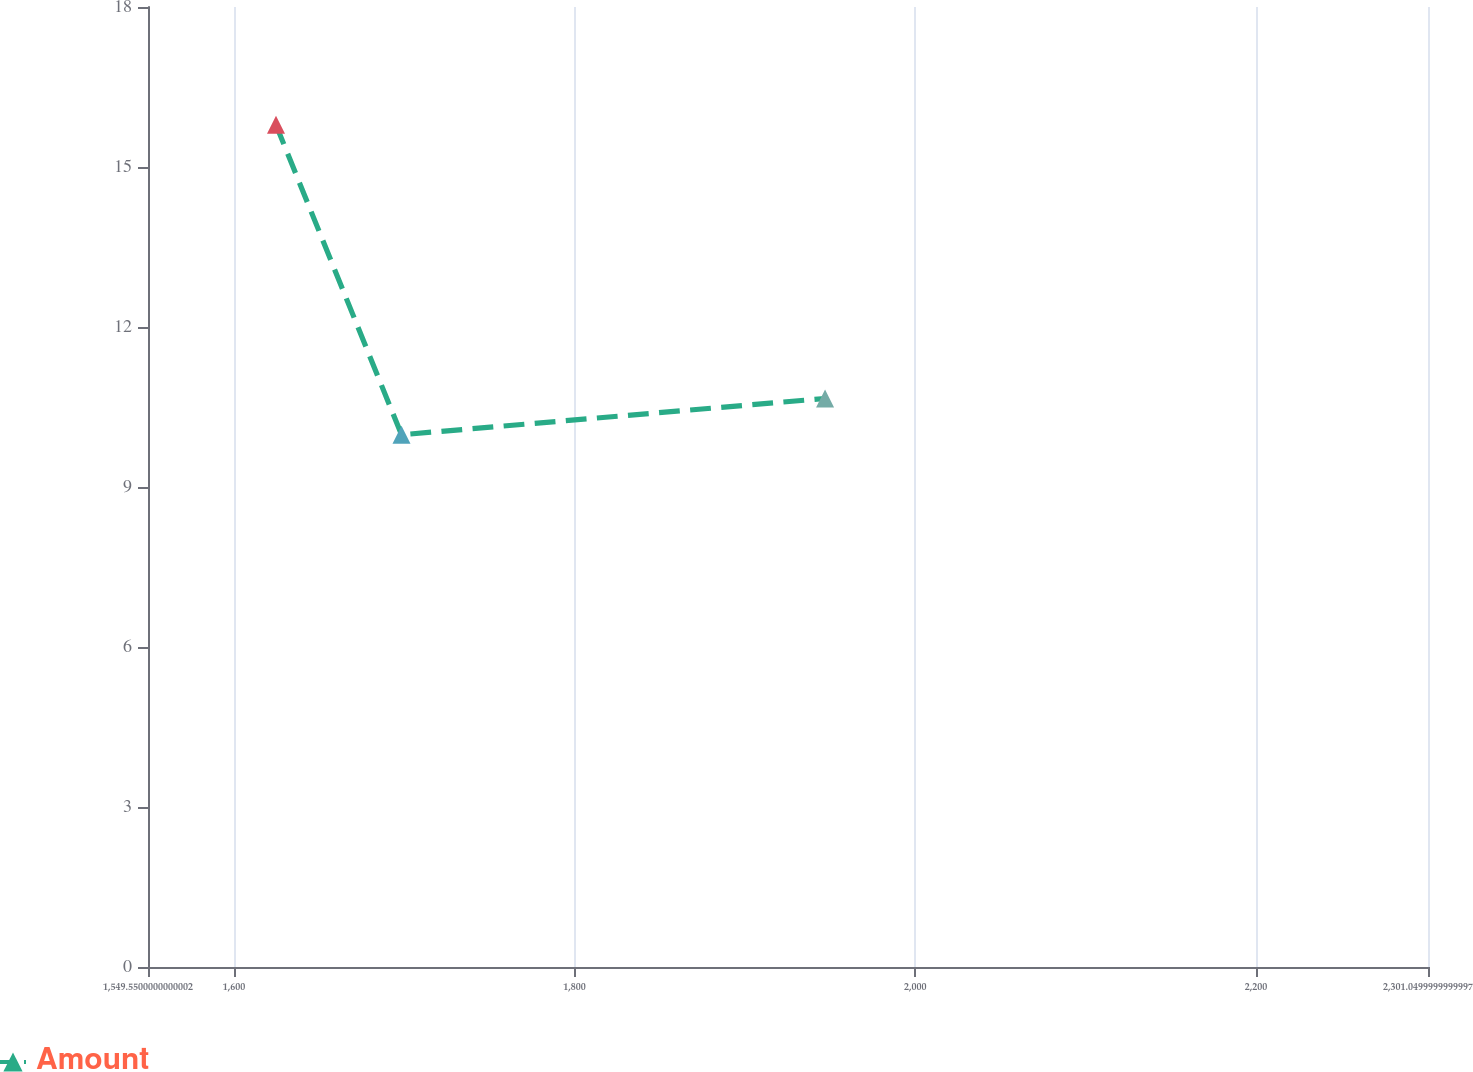<chart> <loc_0><loc_0><loc_500><loc_500><line_chart><ecel><fcel>Amount<nl><fcel>1624.7<fcel>15.79<nl><fcel>1698.4<fcel>9.98<nl><fcel>1947.05<fcel>10.66<nl><fcel>2302.5<fcel>11.38<nl><fcel>2376.2<fcel>11.97<nl></chart> 